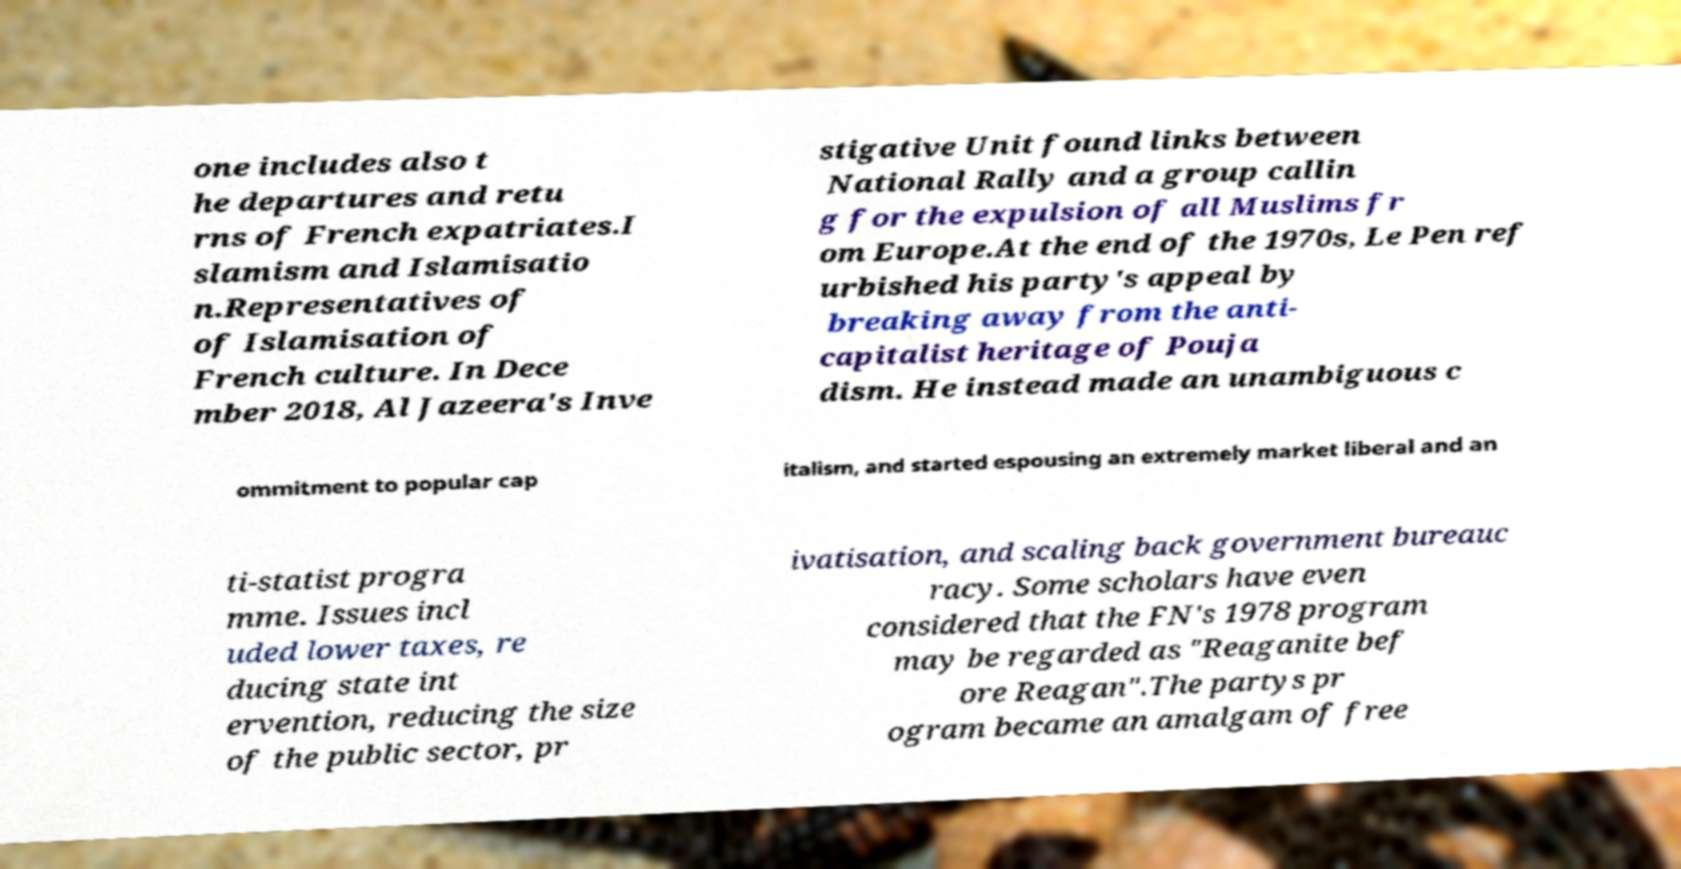There's text embedded in this image that I need extracted. Can you transcribe it verbatim? one includes also t he departures and retu rns of French expatriates.I slamism and Islamisatio n.Representatives of of Islamisation of French culture. In Dece mber 2018, Al Jazeera's Inve stigative Unit found links between National Rally and a group callin g for the expulsion of all Muslims fr om Europe.At the end of the 1970s, Le Pen ref urbished his party's appeal by breaking away from the anti- capitalist heritage of Pouja dism. He instead made an unambiguous c ommitment to popular cap italism, and started espousing an extremely market liberal and an ti-statist progra mme. Issues incl uded lower taxes, re ducing state int ervention, reducing the size of the public sector, pr ivatisation, and scaling back government bureauc racy. Some scholars have even considered that the FN's 1978 program may be regarded as "Reaganite bef ore Reagan".The partys pr ogram became an amalgam of free 